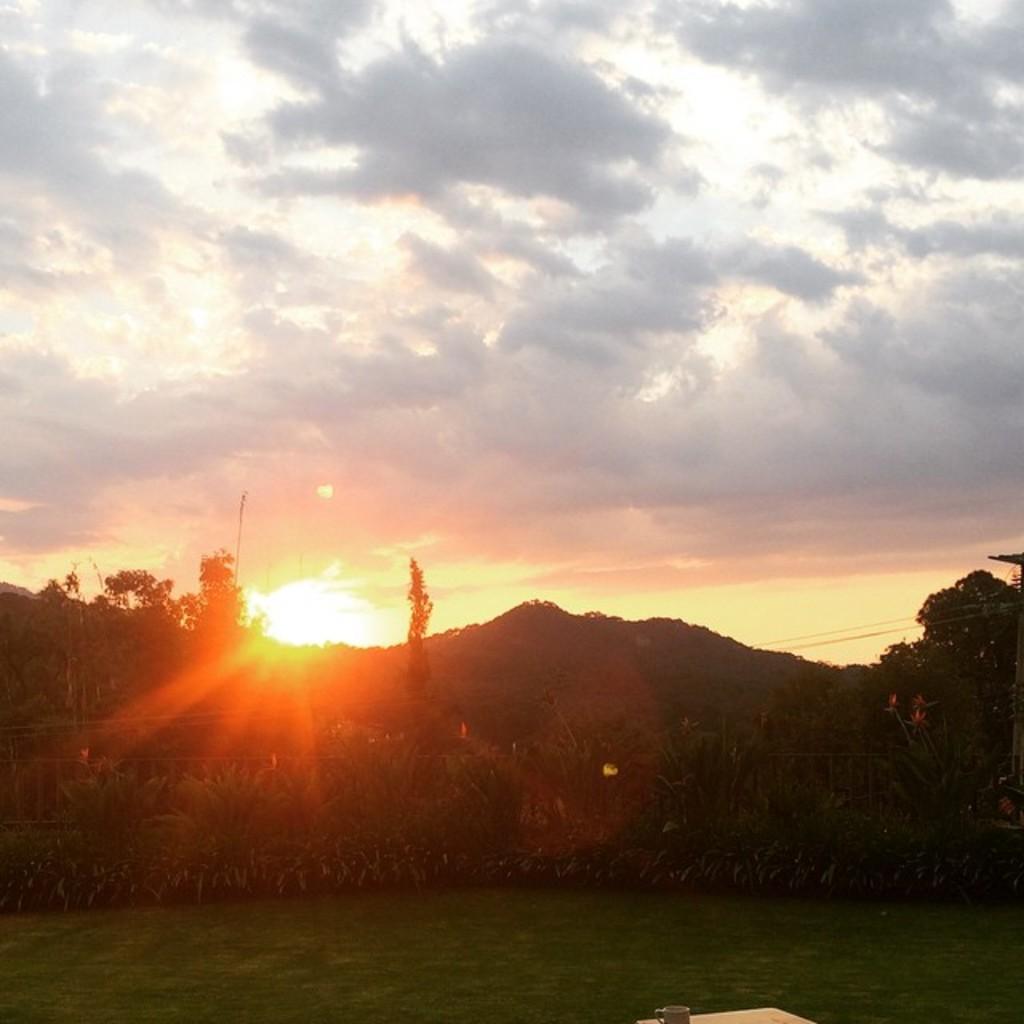In one or two sentences, can you explain what this image depicts? In this image I see the green grass and I see a cup on this surface. In the background I see the plants, trees and I see the sun over here and I see the sky which is a bit cloudy. 